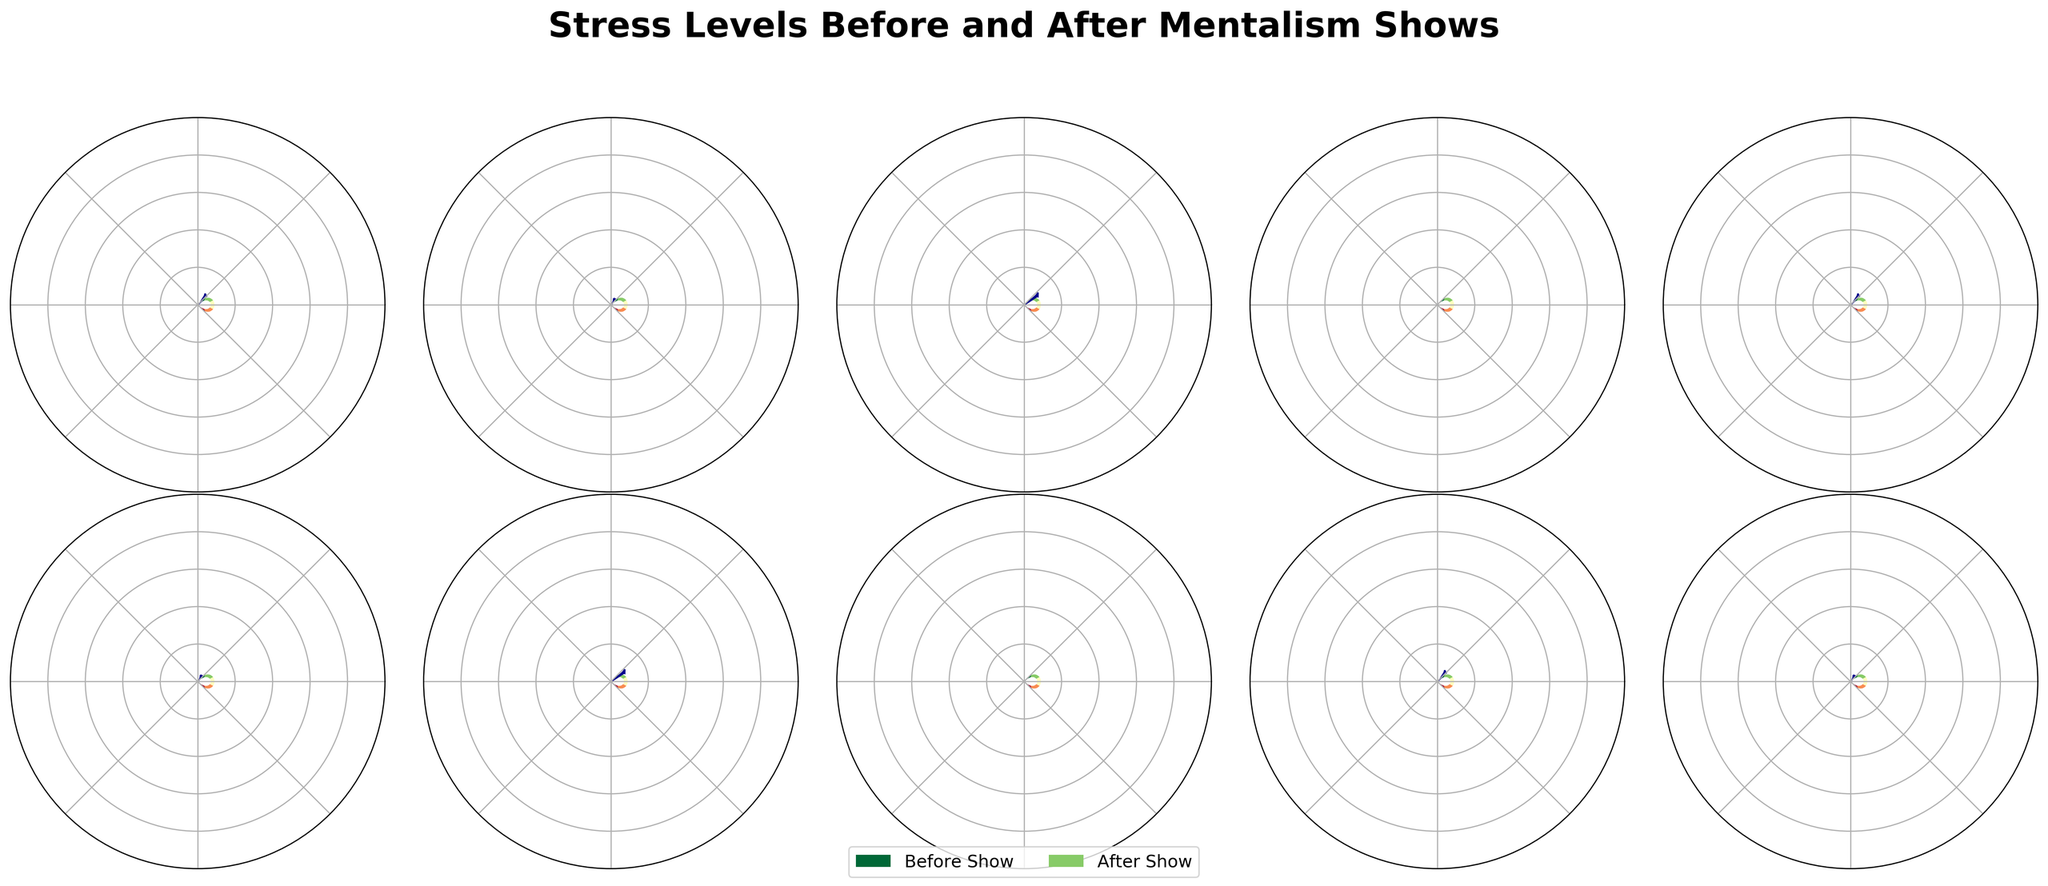What is the title of the chart? The title is typically shown prominently at the top of the chart. It provides a summary of what the chart is about.
Answer: Stress Levels Before and After Mentalism Shows Which participant had the highest stress level before the show? Identify the participant with the highest value in the "Before Show" segment. This is visually indicated by the needle pointing closer to the maximum on the gauge chart.
Answer: Uri Geller Which participant had the lowest stress level after the show? Look for the needle that points closest to the minimum on the gauge chart under the "After Show" segment.
Answer: Keith Barry 